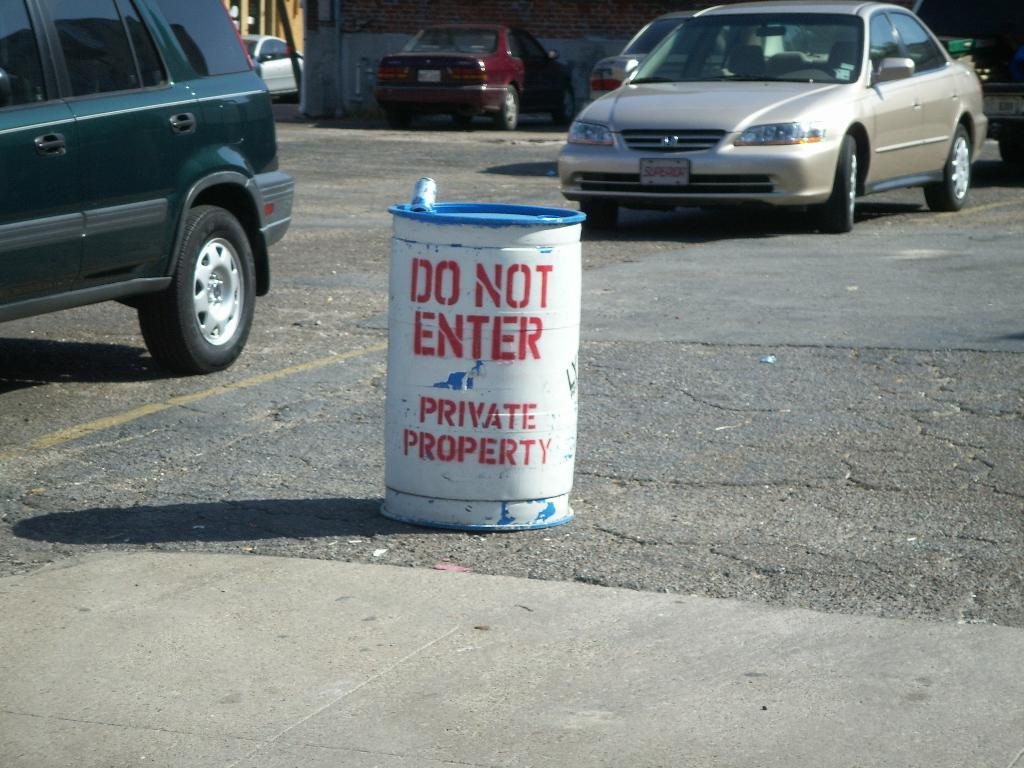<image>
Relay a brief, clear account of the picture shown. A barrel in a parking lot has Do Not Enter painted on it. 